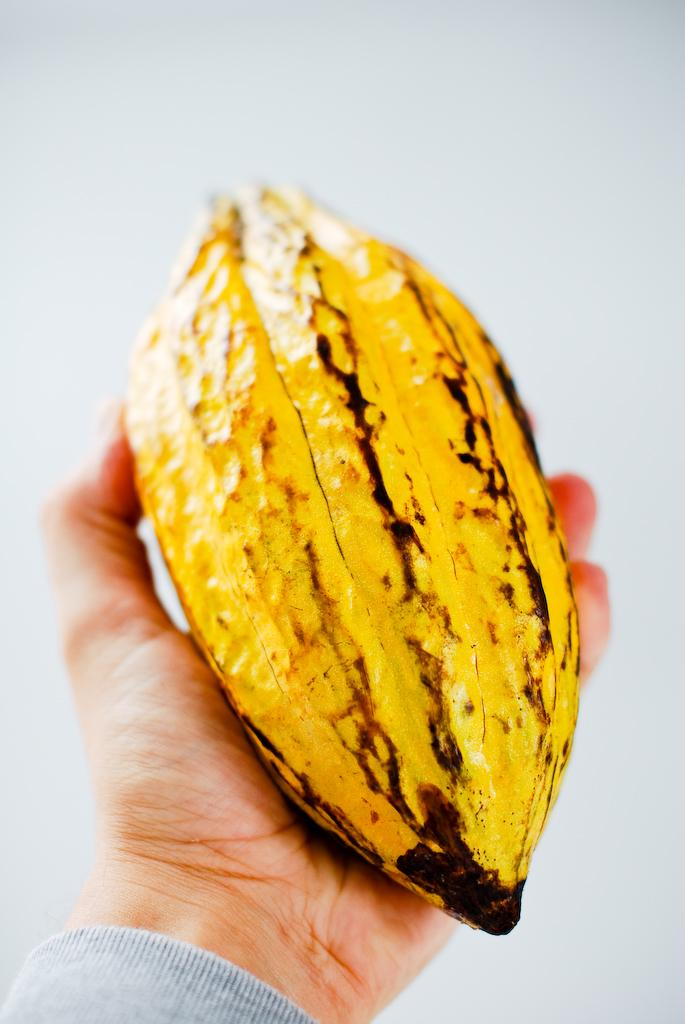What is the main subject of the image? There is a person in the image. What is the person holding in the image? The person is holding a fruit. What type of pet can be seen playing with a tub in the image? There is no pet or tub present in the image; it features a person holding a fruit. What level of difficulty is the person facing while holding the fruit in the image? The level of difficulty is not mentioned or visible in the image, as the person is simply holding a fruit. 